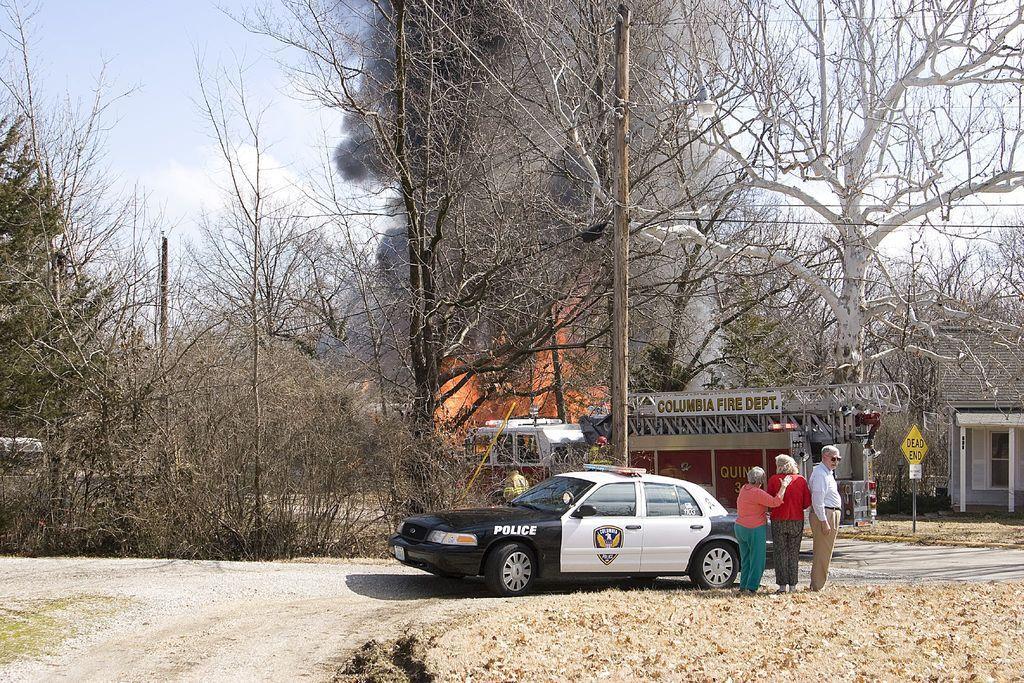Can you describe this image briefly? In this image I can see few dry trees, stores, vehicles, buildings, windows, signboards, pole and the smoke. The sky is in white and blue color. 